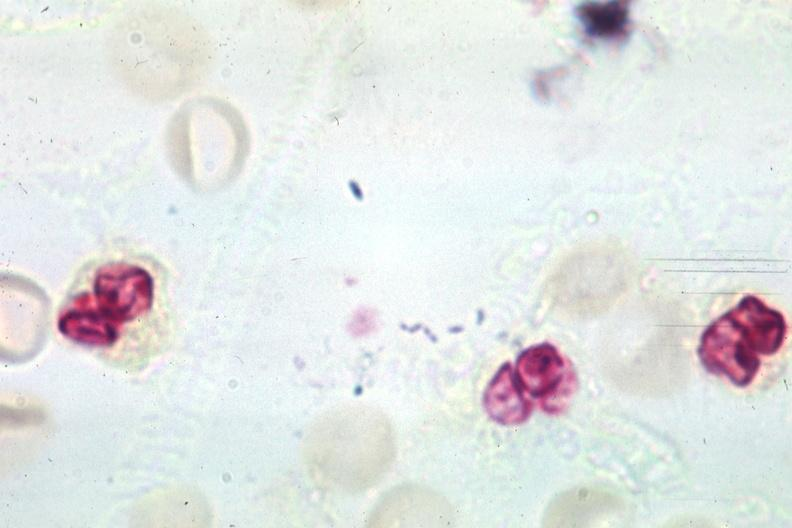does epididymis show gram organisms well shown?
Answer the question using a single word or phrase. No 